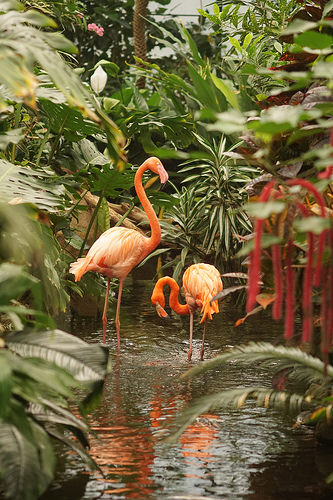<image>
Is the flamingo on the flamingo? No. The flamingo is not positioned on the flamingo. They may be near each other, but the flamingo is not supported by or resting on top of the flamingo. Where is the flamingo in relation to the tree? Is it to the left of the tree? Yes. From this viewpoint, the flamingo is positioned to the left side relative to the tree. 